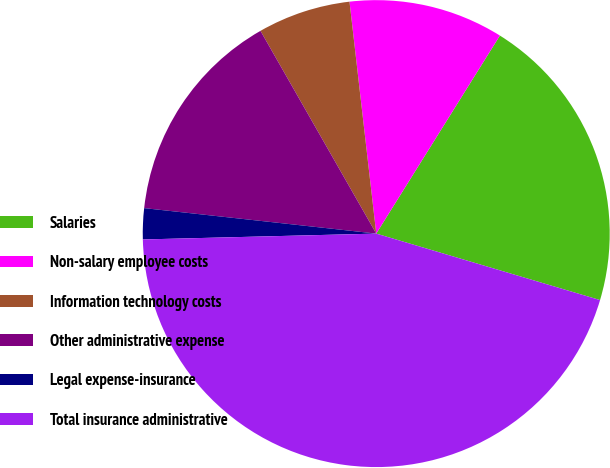Convert chart. <chart><loc_0><loc_0><loc_500><loc_500><pie_chart><fcel>Salaries<fcel>Non-salary employee costs<fcel>Information technology costs<fcel>Other administrative expense<fcel>Legal expense-insurance<fcel>Total insurance administrative<nl><fcel>20.71%<fcel>10.71%<fcel>6.43%<fcel>15.0%<fcel>2.14%<fcel>45.0%<nl></chart> 